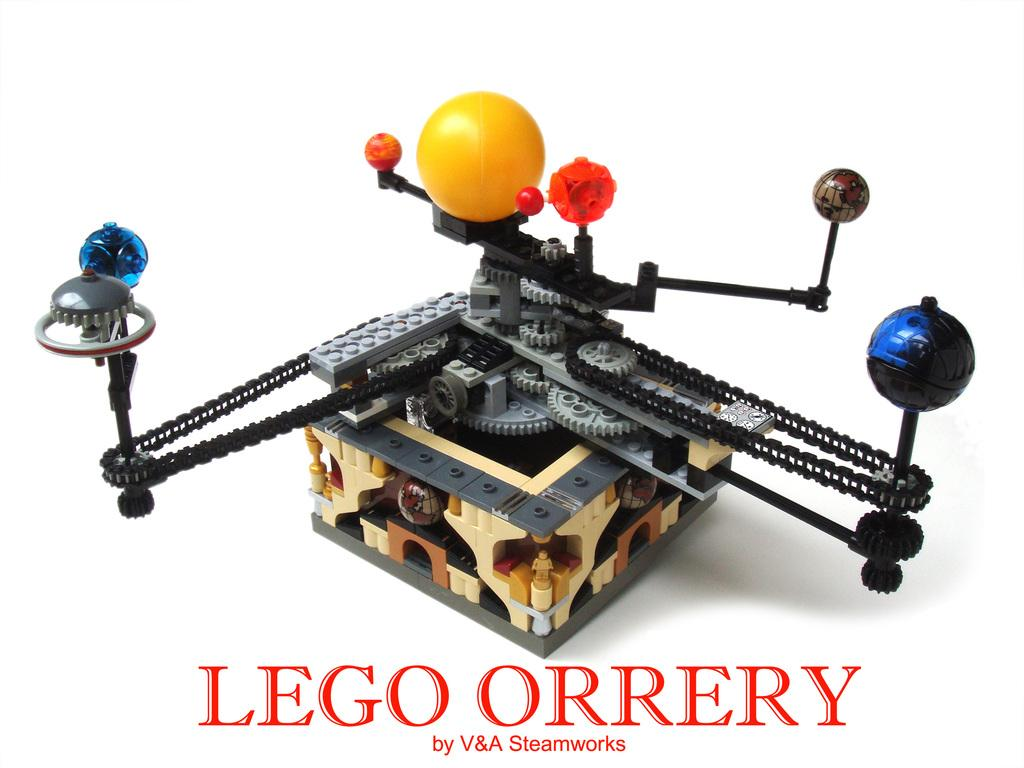What is the main subject of the image? The main subject of the image is a solar system rotating model. What material is the model made of? The model is made by LEGO. How is the model identified in the image? The model is labeled as "LEGO ORRERY". What color is the background of the image? The background of the image is white in color. What type of plant is growing in the background of the image? There is no plant visible in the background of the image; it is white in color. How does the model show respect for the solar system? The model does not show respect for the solar system; it is a representation made by LEGO. 